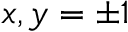<formula> <loc_0><loc_0><loc_500><loc_500>x , y = \pm 1</formula> 